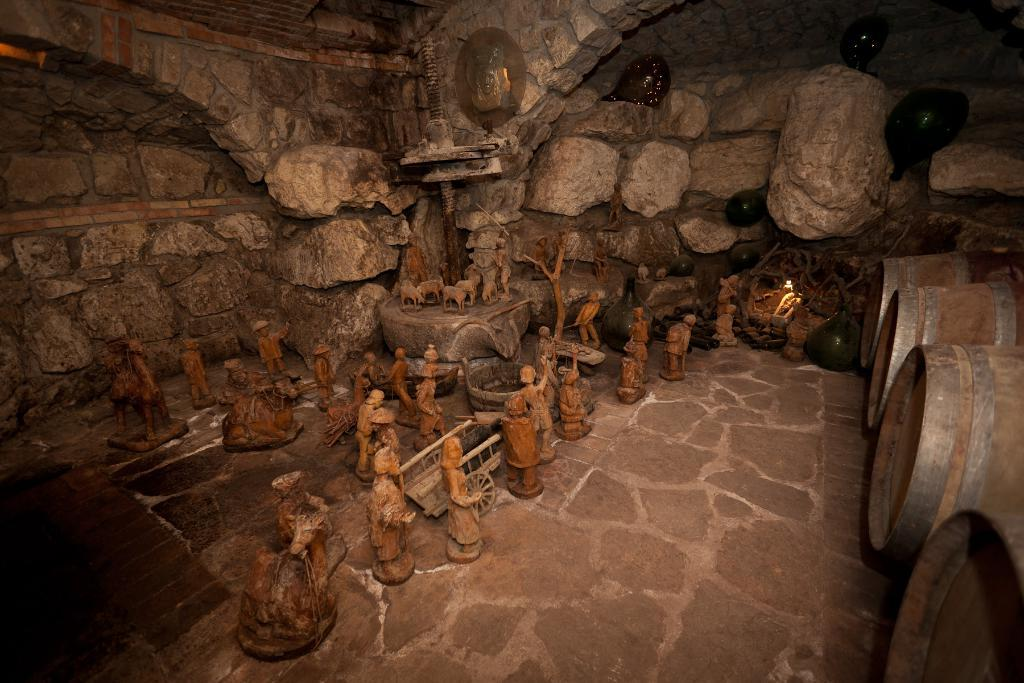What type of art is present in the image? There are sculptures in the image. Where are the sculptures located? The sculptures are placed on the floor. What can be seen in the background of the image? There are walls and bins visible in the background of the image. What type of pan is being used by the robin in the image? There is no robin or pan present in the image. 